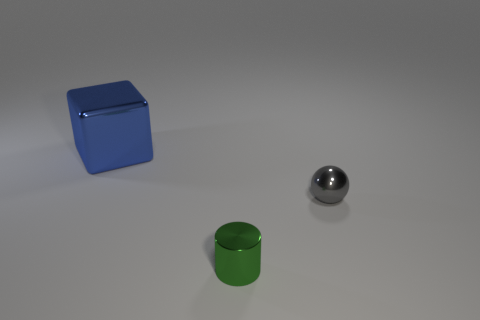Add 1 large yellow metal blocks. How many objects exist? 4 Subtract all spheres. How many objects are left? 2 Add 2 gray things. How many gray things are left? 3 Add 2 yellow things. How many yellow things exist? 2 Subtract 0 yellow balls. How many objects are left? 3 Subtract all small green cylinders. Subtract all gray metallic things. How many objects are left? 1 